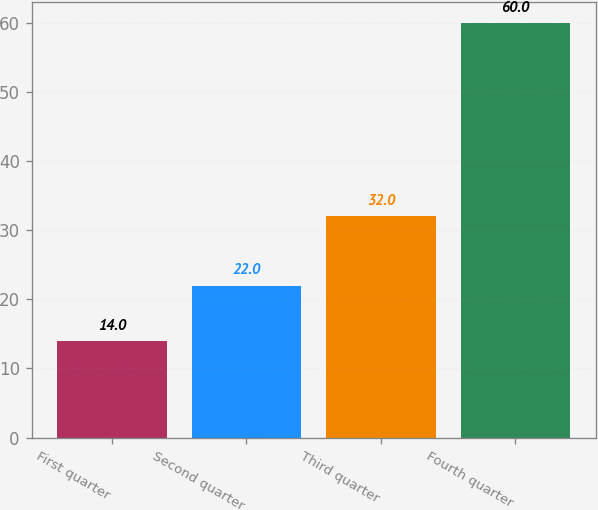<chart> <loc_0><loc_0><loc_500><loc_500><bar_chart><fcel>First quarter<fcel>Second quarter<fcel>Third quarter<fcel>Fourth quarter<nl><fcel>14<fcel>22<fcel>32<fcel>60<nl></chart> 